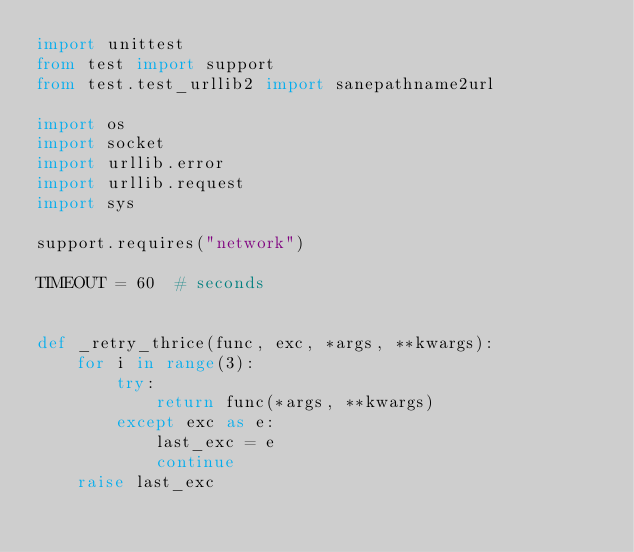Convert code to text. <code><loc_0><loc_0><loc_500><loc_500><_Python_>import unittest
from test import support
from test.test_urllib2 import sanepathname2url

import os
import socket
import urllib.error
import urllib.request
import sys

support.requires("network")

TIMEOUT = 60  # seconds


def _retry_thrice(func, exc, *args, **kwargs):
    for i in range(3):
        try:
            return func(*args, **kwargs)
        except exc as e:
            last_exc = e
            continue
    raise last_exc
</code> 